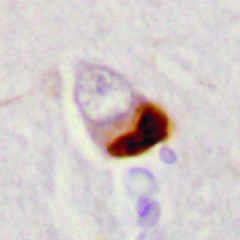what are seen in association with loss of normal nuclear immunoreactivity?
Answer the question using a single word or phrase. Cytoplasmic inclusions containing tdp43 